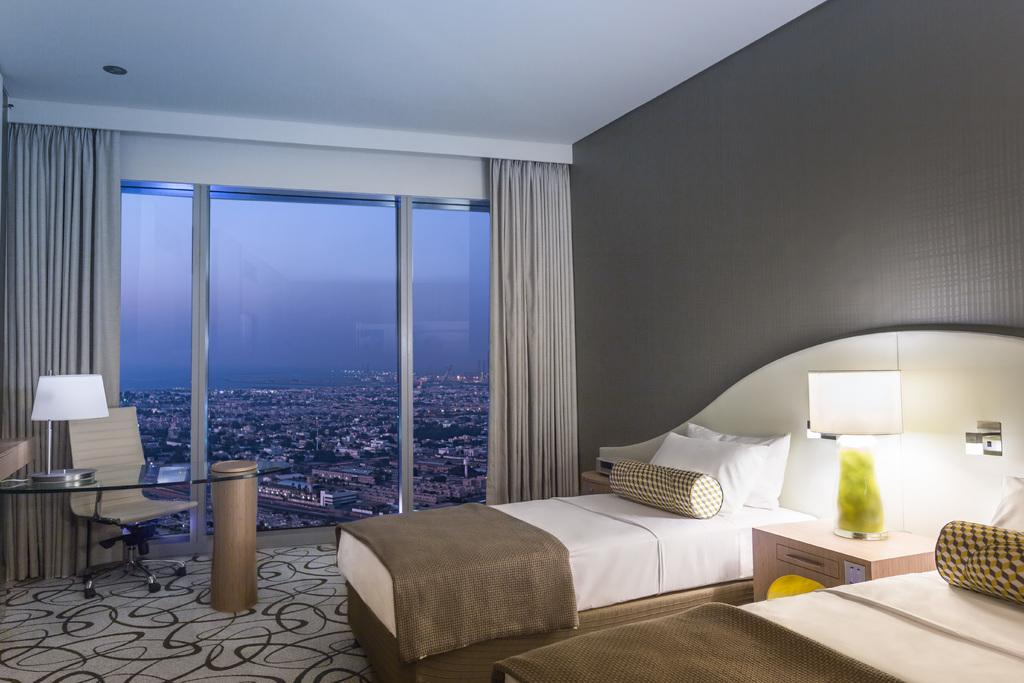How many beds are in the image? There are two beds in the image. What is on the beds? The beds have bed sheets and pillows on them. What furniture can be seen in the image besides the beds? There are tables, lamps, and a chair on the floor in the image. What is the purpose of the glass in the image? The glass allows buildings and the sky to be visible through it. What type of window treatment is present in the image? There are curtains in the image. Can you see a nest in the image? There is no nest present in the image. Is there a coil visible on the floor in the image? There is no coil visible on the floor in the image. 